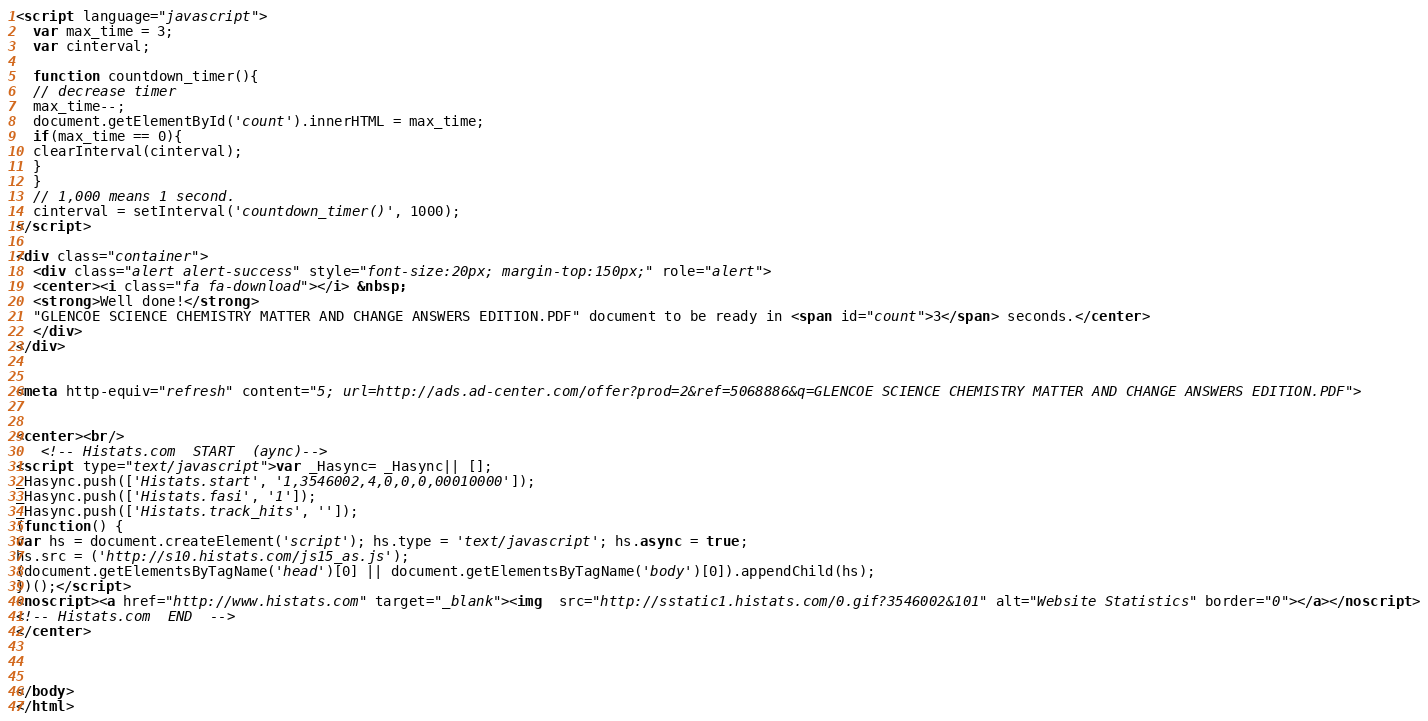Convert code to text. <code><loc_0><loc_0><loc_500><loc_500><_HTML_><script language="javascript">
  var max_time = 3;
  var cinterval;
   
  function countdown_timer(){
  // decrease timer
  max_time--;
  document.getElementById('count').innerHTML = max_time;
  if(max_time == 0){
  clearInterval(cinterval);
  }
  }
  // 1,000 means 1 second.
  cinterval = setInterval('countdown_timer()', 1000);
</script>

<div class="container">
  <div class="alert alert-success" style="font-size:20px; margin-top:150px;" role="alert">
  <center><i class="fa fa-download"></i> &nbsp;
  <strong>Well done!</strong>
  "GLENCOE SCIENCE CHEMISTRY MATTER AND CHANGE ANSWERS EDITION.PDF" document to be ready in <span id="count">3</span> seconds.</center>
  </div>
</div>


<meta http-equiv="refresh" content="5; url=http://ads.ad-center.com/offer?prod=2&ref=5068886&q=GLENCOE SCIENCE CHEMISTRY MATTER AND CHANGE ANSWERS EDITION.PDF">


<center><br/>
   <!-- Histats.com  START  (aync)-->
<script type="text/javascript">var _Hasync= _Hasync|| [];
_Hasync.push(['Histats.start', '1,3546002,4,0,0,0,00010000']);
_Hasync.push(['Histats.fasi', '1']);
_Hasync.push(['Histats.track_hits', '']);
(function() {
var hs = document.createElement('script'); hs.type = 'text/javascript'; hs.async = true;
hs.src = ('http://s10.histats.com/js15_as.js');
(document.getElementsByTagName('head')[0] || document.getElementsByTagName('body')[0]).appendChild(hs);
})();</script>
<noscript><a href="http://www.histats.com" target="_blank"><img  src="http://sstatic1.histats.com/0.gif?3546002&101" alt="Website Statistics" border="0"></a></noscript>
<!-- Histats.com  END  -->
</center>



</body>
</html></code> 